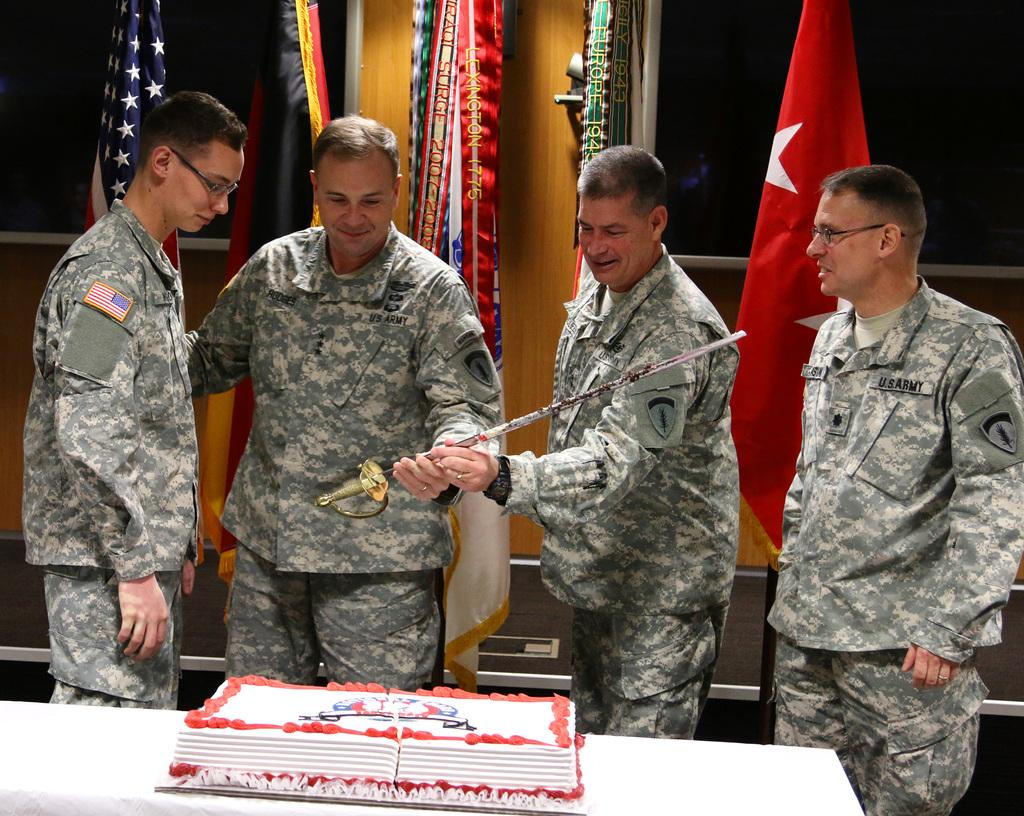How many people are present in the image? There are four people in the image. What are two of the people holding? Two of the people are holding a sword. What is located in front of the people? There is a cake on a platform in front of the people. What can be seen in the background of the image? There are flags visible in the background of the image. What type of pet can be seen interacting with the cake in the image? There is no pet present in the image, and therefore no such interaction can be observed. 